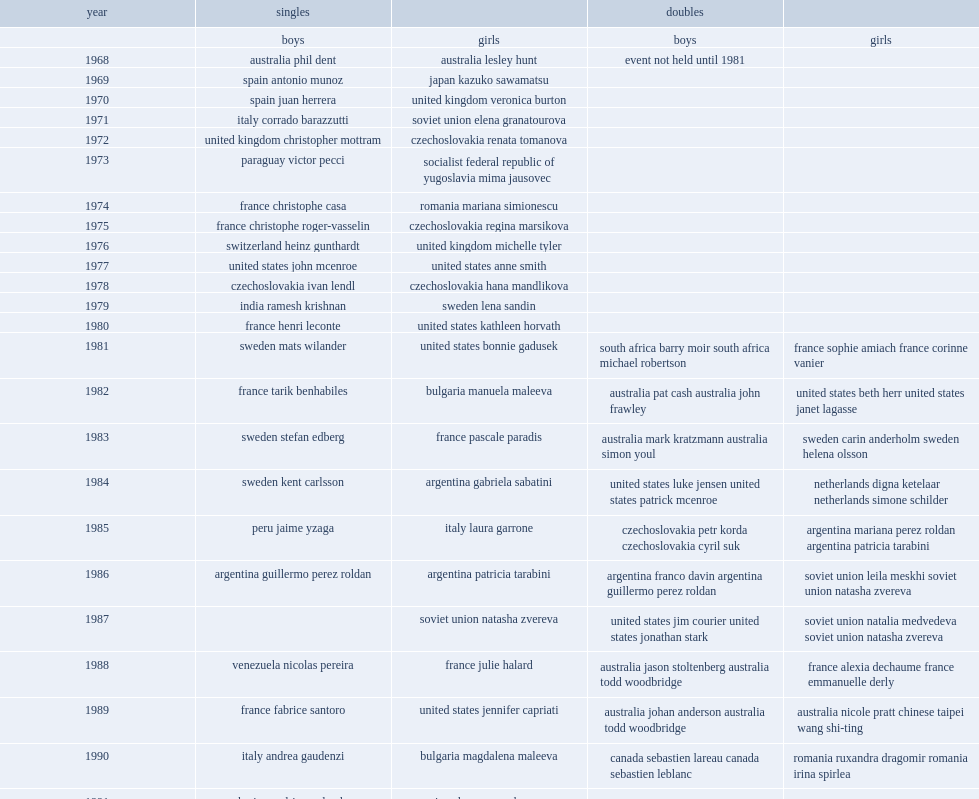When did sophie amiach win the first junior girls doubles at french open? 1981.0. 